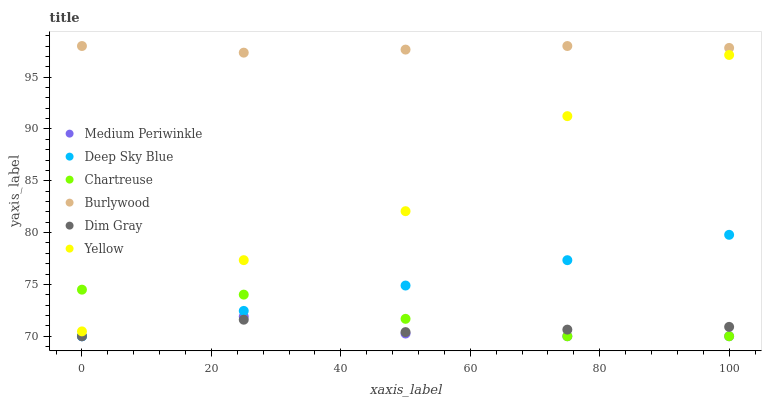Does Medium Periwinkle have the minimum area under the curve?
Answer yes or no. Yes. Does Burlywood have the maximum area under the curve?
Answer yes or no. Yes. Does Burlywood have the minimum area under the curve?
Answer yes or no. No. Does Medium Periwinkle have the maximum area under the curve?
Answer yes or no. No. Is Deep Sky Blue the smoothest?
Answer yes or no. Yes. Is Yellow the roughest?
Answer yes or no. Yes. Is Burlywood the smoothest?
Answer yes or no. No. Is Burlywood the roughest?
Answer yes or no. No. Does Dim Gray have the lowest value?
Answer yes or no. Yes. Does Burlywood have the lowest value?
Answer yes or no. No. Does Burlywood have the highest value?
Answer yes or no. Yes. Does Medium Periwinkle have the highest value?
Answer yes or no. No. Is Dim Gray less than Yellow?
Answer yes or no. Yes. Is Burlywood greater than Medium Periwinkle?
Answer yes or no. Yes. Does Deep Sky Blue intersect Chartreuse?
Answer yes or no. Yes. Is Deep Sky Blue less than Chartreuse?
Answer yes or no. No. Is Deep Sky Blue greater than Chartreuse?
Answer yes or no. No. Does Dim Gray intersect Yellow?
Answer yes or no. No. 